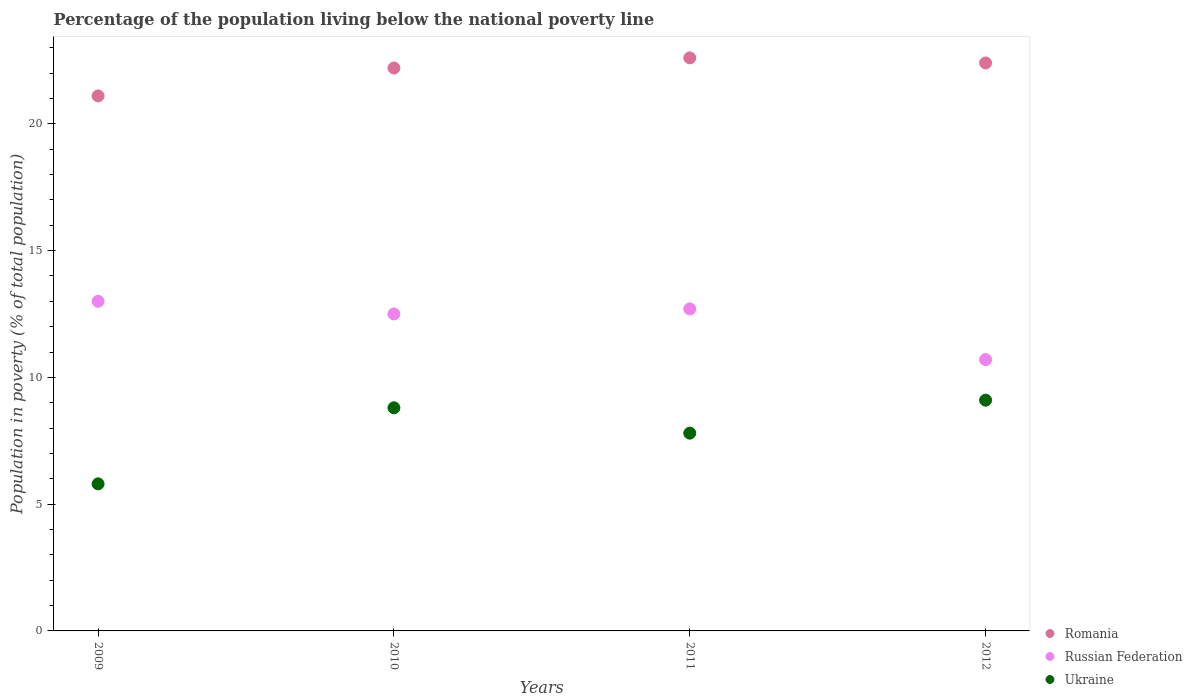How many different coloured dotlines are there?
Provide a short and direct response. 3. Is the number of dotlines equal to the number of legend labels?
Provide a succinct answer. Yes. What is the percentage of the population living below the national poverty line in Romania in 2011?
Your answer should be very brief. 22.6. Across all years, what is the maximum percentage of the population living below the national poverty line in Romania?
Ensure brevity in your answer.  22.6. In which year was the percentage of the population living below the national poverty line in Romania maximum?
Ensure brevity in your answer.  2011. What is the total percentage of the population living below the national poverty line in Russian Federation in the graph?
Ensure brevity in your answer.  48.9. What is the difference between the percentage of the population living below the national poverty line in Russian Federation in 2010 and that in 2011?
Provide a short and direct response. -0.2. What is the difference between the percentage of the population living below the national poverty line in Romania in 2010 and the percentage of the population living below the national poverty line in Ukraine in 2009?
Keep it short and to the point. 16.4. What is the average percentage of the population living below the national poverty line in Ukraine per year?
Make the answer very short. 7.88. In how many years, is the percentage of the population living below the national poverty line in Russian Federation greater than 6 %?
Your response must be concise. 4. What is the ratio of the percentage of the population living below the national poverty line in Romania in 2009 to that in 2010?
Give a very brief answer. 0.95. What is the difference between the highest and the second highest percentage of the population living below the national poverty line in Russian Federation?
Keep it short and to the point. 0.3. What is the difference between the highest and the lowest percentage of the population living below the national poverty line in Russian Federation?
Ensure brevity in your answer.  2.3. In how many years, is the percentage of the population living below the national poverty line in Russian Federation greater than the average percentage of the population living below the national poverty line in Russian Federation taken over all years?
Make the answer very short. 3. Is the percentage of the population living below the national poverty line in Romania strictly less than the percentage of the population living below the national poverty line in Russian Federation over the years?
Your response must be concise. No. What is the difference between two consecutive major ticks on the Y-axis?
Your response must be concise. 5. Does the graph contain any zero values?
Your answer should be compact. No. How are the legend labels stacked?
Your answer should be very brief. Vertical. What is the title of the graph?
Offer a very short reply. Percentage of the population living below the national poverty line. Does "Kenya" appear as one of the legend labels in the graph?
Your response must be concise. No. What is the label or title of the X-axis?
Make the answer very short. Years. What is the label or title of the Y-axis?
Your response must be concise. Population in poverty (% of total population). What is the Population in poverty (% of total population) in Romania in 2009?
Provide a succinct answer. 21.1. What is the Population in poverty (% of total population) of Ukraine in 2009?
Offer a terse response. 5.8. What is the Population in poverty (% of total population) in Russian Federation in 2010?
Provide a short and direct response. 12.5. What is the Population in poverty (% of total population) of Ukraine in 2010?
Give a very brief answer. 8.8. What is the Population in poverty (% of total population) of Romania in 2011?
Give a very brief answer. 22.6. What is the Population in poverty (% of total population) in Romania in 2012?
Offer a terse response. 22.4. What is the Population in poverty (% of total population) in Russian Federation in 2012?
Your answer should be compact. 10.7. Across all years, what is the maximum Population in poverty (% of total population) of Romania?
Make the answer very short. 22.6. Across all years, what is the maximum Population in poverty (% of total population) of Russian Federation?
Provide a succinct answer. 13. Across all years, what is the maximum Population in poverty (% of total population) of Ukraine?
Make the answer very short. 9.1. Across all years, what is the minimum Population in poverty (% of total population) of Romania?
Your answer should be very brief. 21.1. Across all years, what is the minimum Population in poverty (% of total population) of Russian Federation?
Make the answer very short. 10.7. Across all years, what is the minimum Population in poverty (% of total population) in Ukraine?
Offer a terse response. 5.8. What is the total Population in poverty (% of total population) in Romania in the graph?
Offer a terse response. 88.3. What is the total Population in poverty (% of total population) of Russian Federation in the graph?
Offer a terse response. 48.9. What is the total Population in poverty (% of total population) of Ukraine in the graph?
Offer a very short reply. 31.5. What is the difference between the Population in poverty (% of total population) in Romania in 2009 and that in 2010?
Keep it short and to the point. -1.1. What is the difference between the Population in poverty (% of total population) in Russian Federation in 2009 and that in 2010?
Provide a succinct answer. 0.5. What is the difference between the Population in poverty (% of total population) of Ukraine in 2009 and that in 2010?
Your answer should be very brief. -3. What is the difference between the Population in poverty (% of total population) in Russian Federation in 2009 and that in 2011?
Provide a short and direct response. 0.3. What is the difference between the Population in poverty (% of total population) in Ukraine in 2009 and that in 2012?
Your answer should be very brief. -3.3. What is the difference between the Population in poverty (% of total population) in Romania in 2010 and that in 2011?
Ensure brevity in your answer.  -0.4. What is the difference between the Population in poverty (% of total population) in Ukraine in 2010 and that in 2011?
Make the answer very short. 1. What is the difference between the Population in poverty (% of total population) of Russian Federation in 2010 and that in 2012?
Your answer should be compact. 1.8. What is the difference between the Population in poverty (% of total population) in Ukraine in 2010 and that in 2012?
Provide a succinct answer. -0.3. What is the difference between the Population in poverty (% of total population) of Romania in 2011 and that in 2012?
Your answer should be very brief. 0.2. What is the difference between the Population in poverty (% of total population) in Romania in 2009 and the Population in poverty (% of total population) in Russian Federation in 2010?
Provide a short and direct response. 8.6. What is the difference between the Population in poverty (% of total population) in Romania in 2009 and the Population in poverty (% of total population) in Ukraine in 2010?
Ensure brevity in your answer.  12.3. What is the difference between the Population in poverty (% of total population) of Russian Federation in 2009 and the Population in poverty (% of total population) of Ukraine in 2010?
Provide a succinct answer. 4.2. What is the difference between the Population in poverty (% of total population) of Romania in 2009 and the Population in poverty (% of total population) of Russian Federation in 2011?
Your response must be concise. 8.4. What is the difference between the Population in poverty (% of total population) of Romania in 2009 and the Population in poverty (% of total population) of Ukraine in 2012?
Provide a short and direct response. 12. What is the difference between the Population in poverty (% of total population) of Romania in 2010 and the Population in poverty (% of total population) of Russian Federation in 2011?
Your response must be concise. 9.5. What is the difference between the Population in poverty (% of total population) in Russian Federation in 2010 and the Population in poverty (% of total population) in Ukraine in 2011?
Offer a very short reply. 4.7. What is the difference between the Population in poverty (% of total population) of Russian Federation in 2010 and the Population in poverty (% of total population) of Ukraine in 2012?
Your response must be concise. 3.4. What is the difference between the Population in poverty (% of total population) of Romania in 2011 and the Population in poverty (% of total population) of Russian Federation in 2012?
Offer a terse response. 11.9. What is the difference between the Population in poverty (% of total population) in Russian Federation in 2011 and the Population in poverty (% of total population) in Ukraine in 2012?
Ensure brevity in your answer.  3.6. What is the average Population in poverty (% of total population) of Romania per year?
Your answer should be compact. 22.07. What is the average Population in poverty (% of total population) of Russian Federation per year?
Make the answer very short. 12.22. What is the average Population in poverty (% of total population) in Ukraine per year?
Offer a very short reply. 7.88. In the year 2009, what is the difference between the Population in poverty (% of total population) of Russian Federation and Population in poverty (% of total population) of Ukraine?
Offer a terse response. 7.2. In the year 2010, what is the difference between the Population in poverty (% of total population) in Romania and Population in poverty (% of total population) in Ukraine?
Offer a terse response. 13.4. In the year 2010, what is the difference between the Population in poverty (% of total population) in Russian Federation and Population in poverty (% of total population) in Ukraine?
Your response must be concise. 3.7. In the year 2011, what is the difference between the Population in poverty (% of total population) of Russian Federation and Population in poverty (% of total population) of Ukraine?
Your answer should be very brief. 4.9. In the year 2012, what is the difference between the Population in poverty (% of total population) in Russian Federation and Population in poverty (% of total population) in Ukraine?
Your answer should be very brief. 1.6. What is the ratio of the Population in poverty (% of total population) in Romania in 2009 to that in 2010?
Make the answer very short. 0.95. What is the ratio of the Population in poverty (% of total population) of Ukraine in 2009 to that in 2010?
Provide a succinct answer. 0.66. What is the ratio of the Population in poverty (% of total population) of Romania in 2009 to that in 2011?
Make the answer very short. 0.93. What is the ratio of the Population in poverty (% of total population) of Russian Federation in 2009 to that in 2011?
Provide a short and direct response. 1.02. What is the ratio of the Population in poverty (% of total population) of Ukraine in 2009 to that in 2011?
Your answer should be compact. 0.74. What is the ratio of the Population in poverty (% of total population) of Romania in 2009 to that in 2012?
Give a very brief answer. 0.94. What is the ratio of the Population in poverty (% of total population) of Russian Federation in 2009 to that in 2012?
Keep it short and to the point. 1.22. What is the ratio of the Population in poverty (% of total population) in Ukraine in 2009 to that in 2012?
Give a very brief answer. 0.64. What is the ratio of the Population in poverty (% of total population) in Romania in 2010 to that in 2011?
Give a very brief answer. 0.98. What is the ratio of the Population in poverty (% of total population) of Russian Federation in 2010 to that in 2011?
Ensure brevity in your answer.  0.98. What is the ratio of the Population in poverty (% of total population) of Ukraine in 2010 to that in 2011?
Your answer should be compact. 1.13. What is the ratio of the Population in poverty (% of total population) of Romania in 2010 to that in 2012?
Offer a very short reply. 0.99. What is the ratio of the Population in poverty (% of total population) in Russian Federation in 2010 to that in 2012?
Ensure brevity in your answer.  1.17. What is the ratio of the Population in poverty (% of total population) in Ukraine in 2010 to that in 2012?
Offer a very short reply. 0.97. What is the ratio of the Population in poverty (% of total population) of Romania in 2011 to that in 2012?
Make the answer very short. 1.01. What is the ratio of the Population in poverty (% of total population) of Russian Federation in 2011 to that in 2012?
Ensure brevity in your answer.  1.19. What is the ratio of the Population in poverty (% of total population) in Ukraine in 2011 to that in 2012?
Offer a terse response. 0.86. What is the difference between the highest and the second highest Population in poverty (% of total population) of Romania?
Your answer should be compact. 0.2. What is the difference between the highest and the second highest Population in poverty (% of total population) in Ukraine?
Offer a very short reply. 0.3. What is the difference between the highest and the lowest Population in poverty (% of total population) of Russian Federation?
Your response must be concise. 2.3. What is the difference between the highest and the lowest Population in poverty (% of total population) of Ukraine?
Keep it short and to the point. 3.3. 